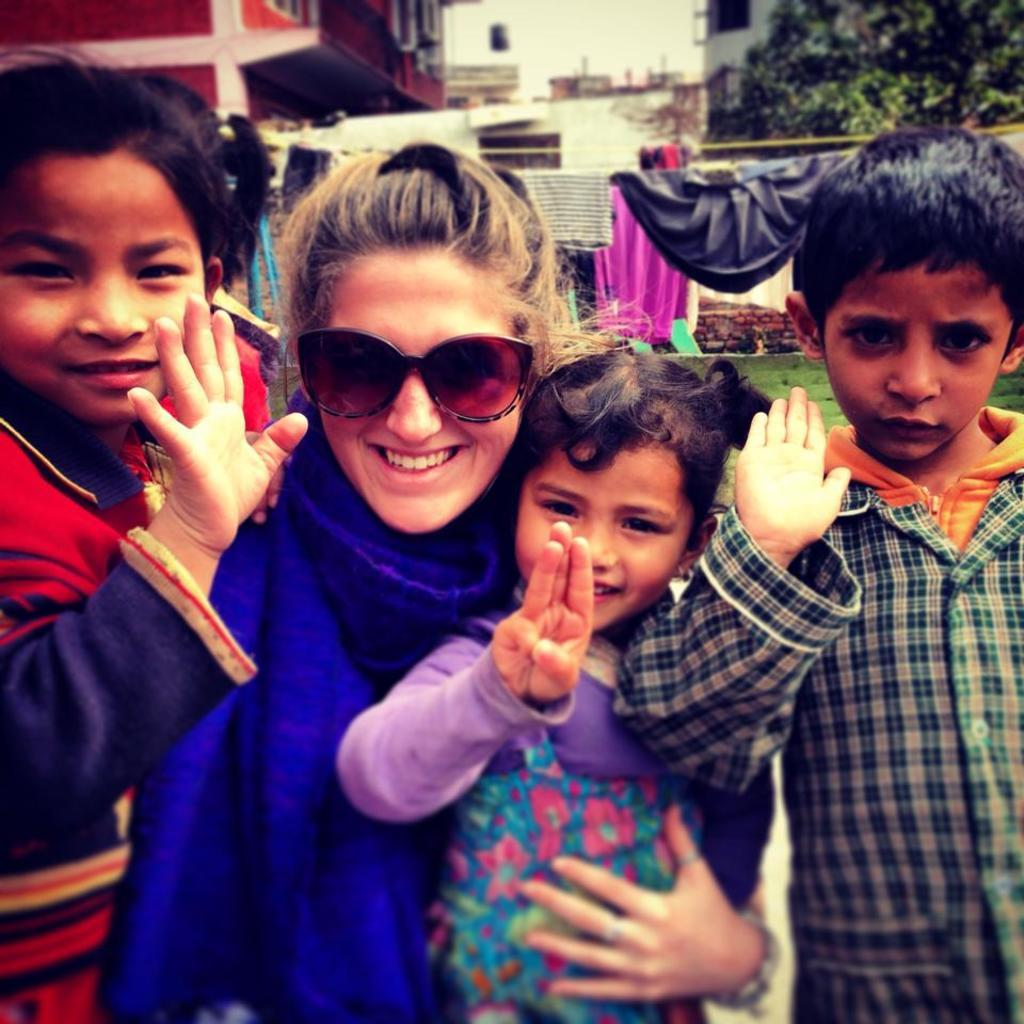What can be seen in the image? There are people standing in the image. Where are the people standing? The people are standing on the floor. What can be seen in the distance in the image? There are buildings and trees in the background of the image. What type of surface is at the bottom of the image? There is grass on the surface at the bottom of the image. Can you see any quince trees in the image? There are no quince trees present in the image. Are the people in the image smiling? The provided facts do not mention the facial expressions of the people in the image, so it cannot be determined if they are smiling. 